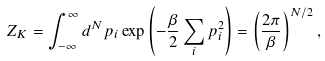Convert formula to latex. <formula><loc_0><loc_0><loc_500><loc_500>Z _ { K } = \int _ { - \infty } ^ { \infty } d ^ { N } p _ { i } \exp { \left ( - \frac { \beta } { 2 } \sum _ { i } p _ { i } ^ { 2 } \right ) } = \left ( \frac { 2 \pi } { \beta } \right ) ^ { N / 2 } ,</formula> 